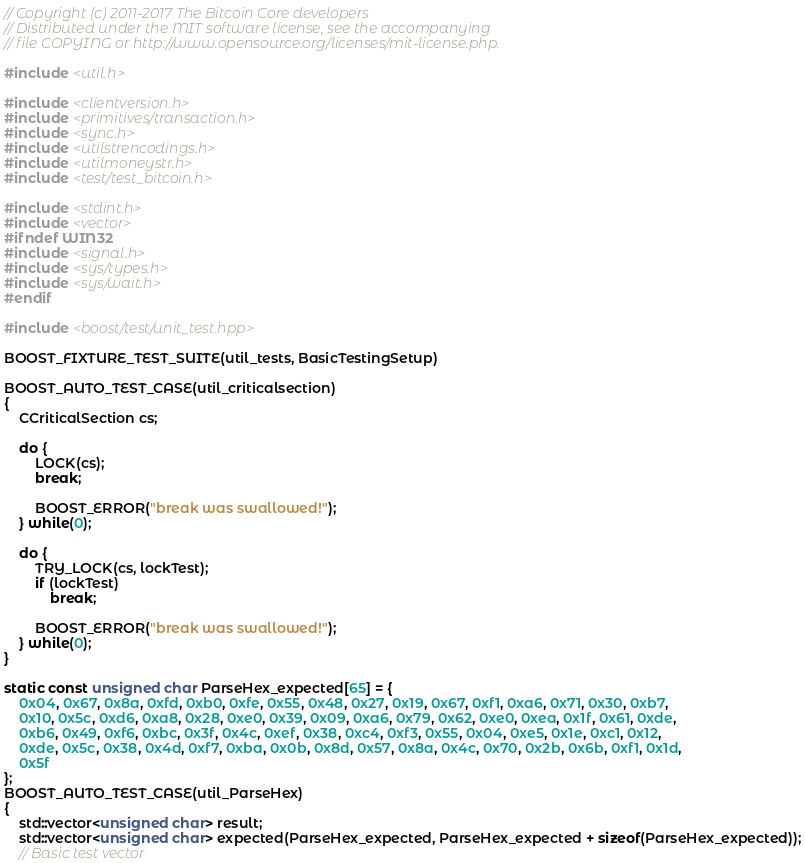<code> <loc_0><loc_0><loc_500><loc_500><_C++_>// Copyright (c) 2011-2017 The Bitcoin Core developers
// Distributed under the MIT software license, see the accompanying
// file COPYING or http://www.opensource.org/licenses/mit-license.php.

#include <util.h>

#include <clientversion.h>
#include <primitives/transaction.h>
#include <sync.h>
#include <utilstrencodings.h>
#include <utilmoneystr.h>
#include <test/test_bitcoin.h>

#include <stdint.h>
#include <vector>
#ifndef WIN32
#include <signal.h>
#include <sys/types.h>
#include <sys/wait.h>
#endif

#include <boost/test/unit_test.hpp>

BOOST_FIXTURE_TEST_SUITE(util_tests, BasicTestingSetup)

BOOST_AUTO_TEST_CASE(util_criticalsection)
{
    CCriticalSection cs;

    do {
        LOCK(cs);
        break;

        BOOST_ERROR("break was swallowed!");
    } while(0);

    do {
        TRY_LOCK(cs, lockTest);
        if (lockTest)
            break;

        BOOST_ERROR("break was swallowed!");
    } while(0);
}

static const unsigned char ParseHex_expected[65] = {
    0x04, 0x67, 0x8a, 0xfd, 0xb0, 0xfe, 0x55, 0x48, 0x27, 0x19, 0x67, 0xf1, 0xa6, 0x71, 0x30, 0xb7,
    0x10, 0x5c, 0xd6, 0xa8, 0x28, 0xe0, 0x39, 0x09, 0xa6, 0x79, 0x62, 0xe0, 0xea, 0x1f, 0x61, 0xde,
    0xb6, 0x49, 0xf6, 0xbc, 0x3f, 0x4c, 0xef, 0x38, 0xc4, 0xf3, 0x55, 0x04, 0xe5, 0x1e, 0xc1, 0x12,
    0xde, 0x5c, 0x38, 0x4d, 0xf7, 0xba, 0x0b, 0x8d, 0x57, 0x8a, 0x4c, 0x70, 0x2b, 0x6b, 0xf1, 0x1d,
    0x5f
};
BOOST_AUTO_TEST_CASE(util_ParseHex)
{
    std::vector<unsigned char> result;
    std::vector<unsigned char> expected(ParseHex_expected, ParseHex_expected + sizeof(ParseHex_expected));
    // Basic test vector</code> 